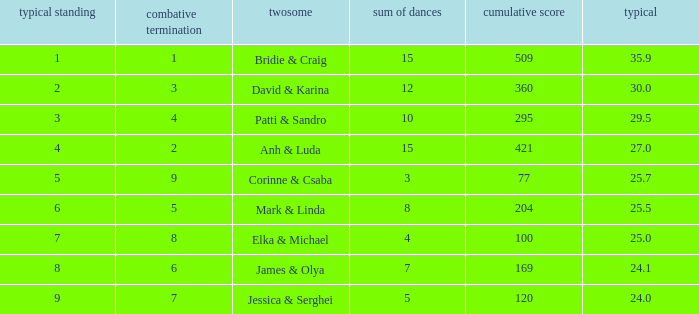What is the total score when 7 is the average ranking? 100.0. 